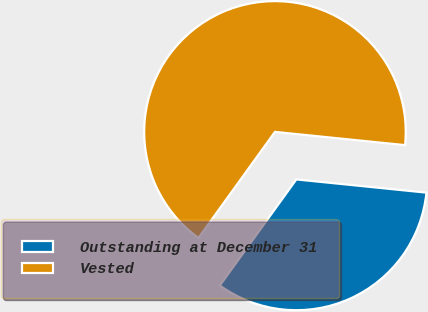<chart> <loc_0><loc_0><loc_500><loc_500><pie_chart><fcel>Outstanding at December 31<fcel>Vested<nl><fcel>33.33%<fcel>66.67%<nl></chart> 